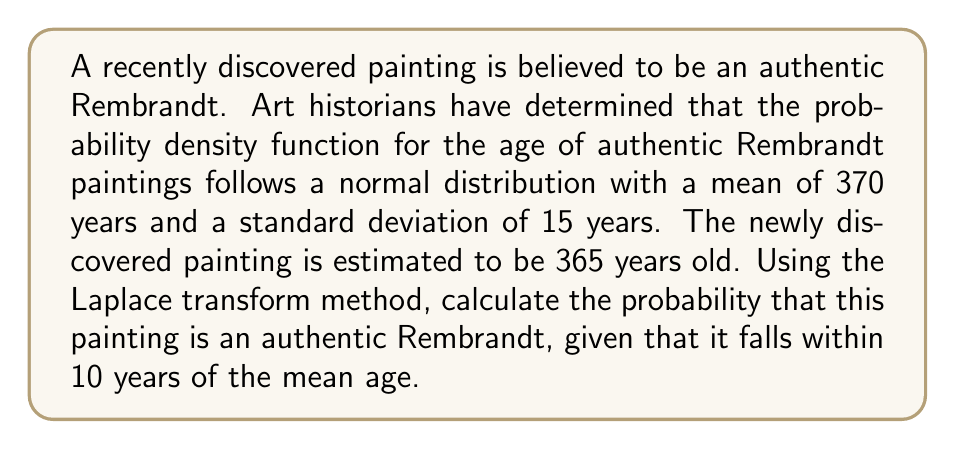Could you help me with this problem? To solve this problem, we'll use the Laplace transform method and the properties of the normal distribution. Let's break it down step-by-step:

1) First, we need to standardize the given values:
   Mean (μ) = 370 years
   Standard deviation (σ) = 15 years
   Age of the painting = 365 years
   Range = ±10 years from the mean

2) Calculate the z-scores for the range:
   Lower bound: $z_1 = \frac{360 - 370}{15} = -\frac{2}{3}$
   Upper bound: $z_2 = \frac{380 - 370}{15} = \frac{2}{3}$

3) The probability we're looking for is the area under the standard normal curve between these z-scores. We can use the Laplace transform of the standard normal distribution:

   $$\mathcal{L}\{f(t)\} = F(s) = e^{\frac{s^2}{2}}$$

4) The probability is given by the inverse Laplace transform of $\frac{F(s)}{s}$ evaluated at the upper and lower bounds:

   $$P(-\frac{2}{3} < Z < \frac{2}{3}) = \mathcal{L}^{-1}\{\frac{e^{\frac{s^2}{2}}}{s}\}|_{-\frac{2}{3}}^{\frac{2}{3}}$$

5) This inverse Laplace transform evaluates to the error function (erf):

   $$P(-\frac{2}{3} < Z < \frac{2}{3}) = \frac{1}{2}[erf(\frac{2}{3\sqrt{2}}) - erf(-\frac{2}{3\sqrt{2}})]$$

6) Since erf is an odd function, erf(-x) = -erf(x), so:

   $$P(-\frac{2}{3} < Z < \frac{2}{3}) = erf(\frac{2}{3\sqrt{2}})$$

7) Evaluating this (you can use a calculator or statistical tables):

   $$erf(\frac{2}{3\sqrt{2}}) \approx 0.4950$$

Therefore, the probability that the painting is an authentic Rembrandt, given that it falls within 10 years of the mean age, is approximately 0.4950 or 49.50%.
Answer: 0.4950 or 49.50% 